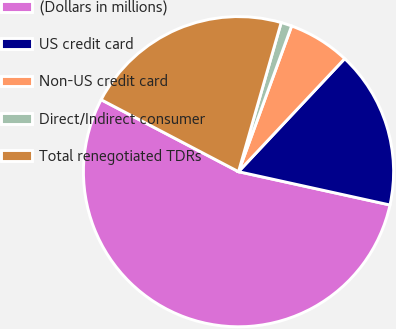Convert chart to OTSL. <chart><loc_0><loc_0><loc_500><loc_500><pie_chart><fcel>(Dollars in millions)<fcel>US credit card<fcel>Non-US credit card<fcel>Direct/Indirect consumer<fcel>Total renegotiated TDRs<nl><fcel>54.23%<fcel>16.44%<fcel>6.44%<fcel>1.13%<fcel>21.75%<nl></chart> 